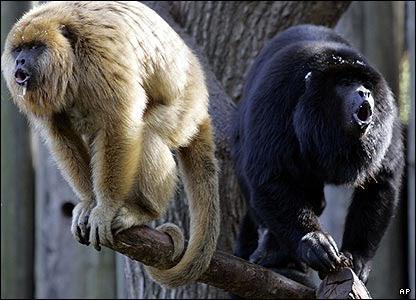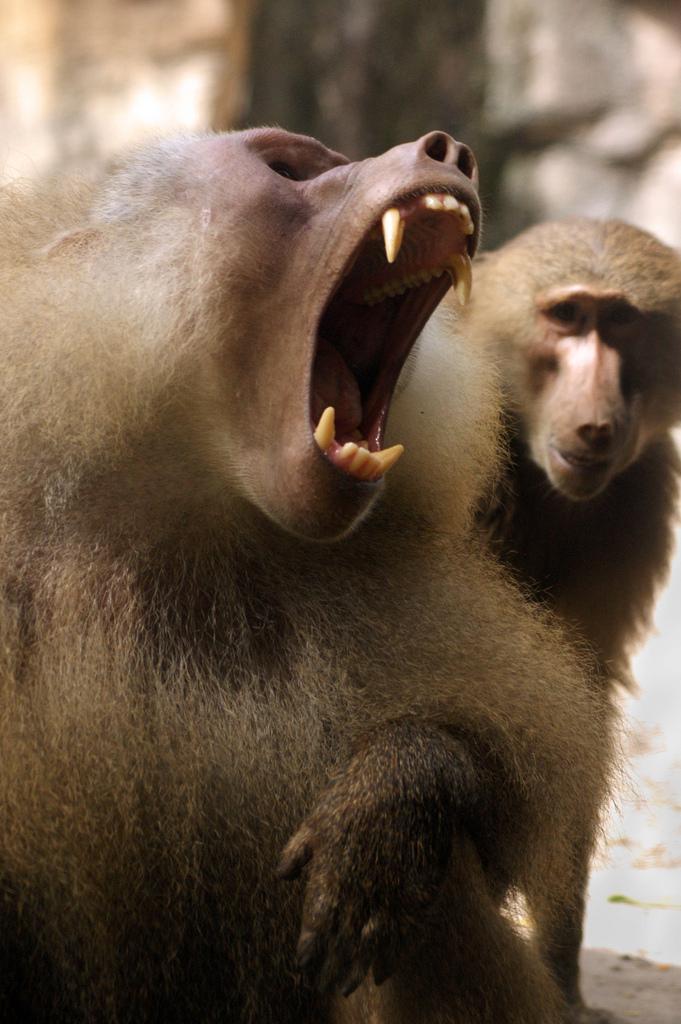The first image is the image on the left, the second image is the image on the right. Given the left and right images, does the statement "Each image shows one open-mouthed, fang-baring monkey, and one image shows a monkey with an upturned snout and open mouth." hold true? Answer yes or no. No. The first image is the image on the left, the second image is the image on the right. Assess this claim about the two images: "At least one primate is on a log or branch.". Correct or not? Answer yes or no. Yes. 